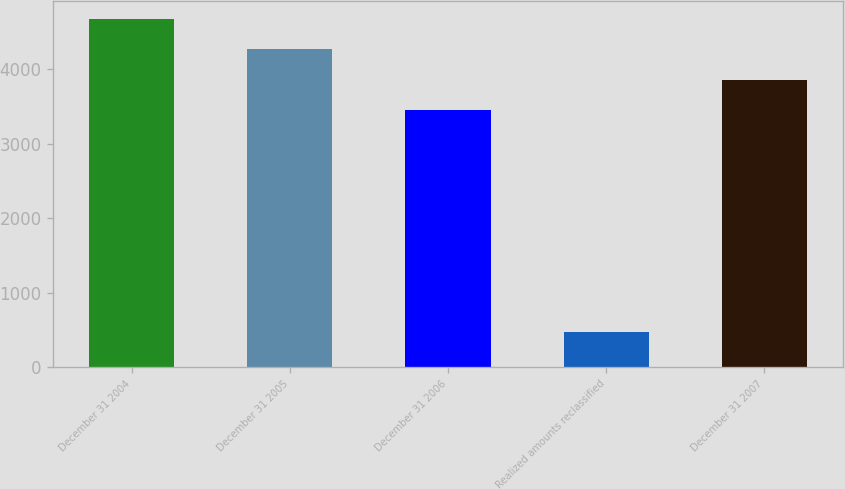Convert chart. <chart><loc_0><loc_0><loc_500><loc_500><bar_chart><fcel>December 31 2004<fcel>December 31 2005<fcel>December 31 2006<fcel>Realized amounts reclassified<fcel>December 31 2007<nl><fcel>4679.2<fcel>4268.8<fcel>3448<fcel>473<fcel>3858.4<nl></chart> 